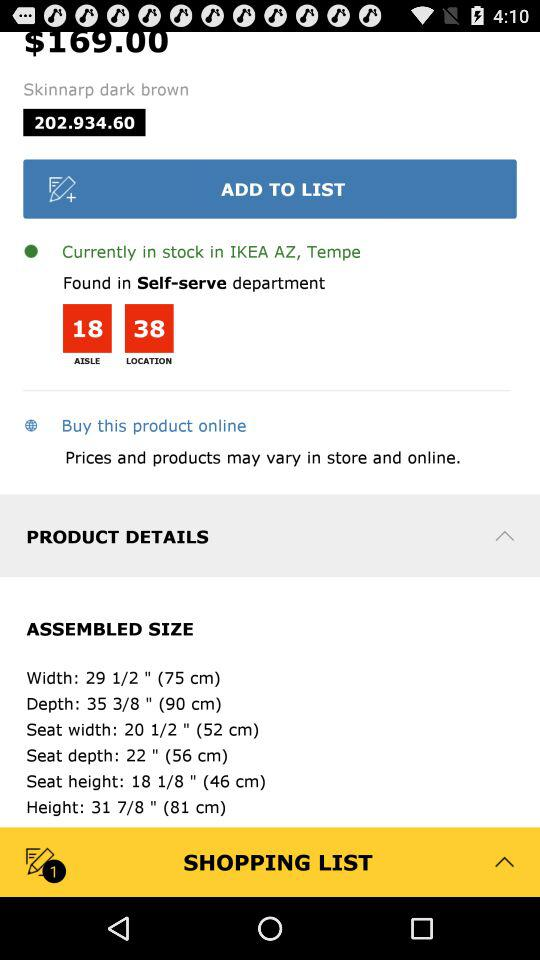How much is the product?
Answer the question using a single word or phrase. $169.00 